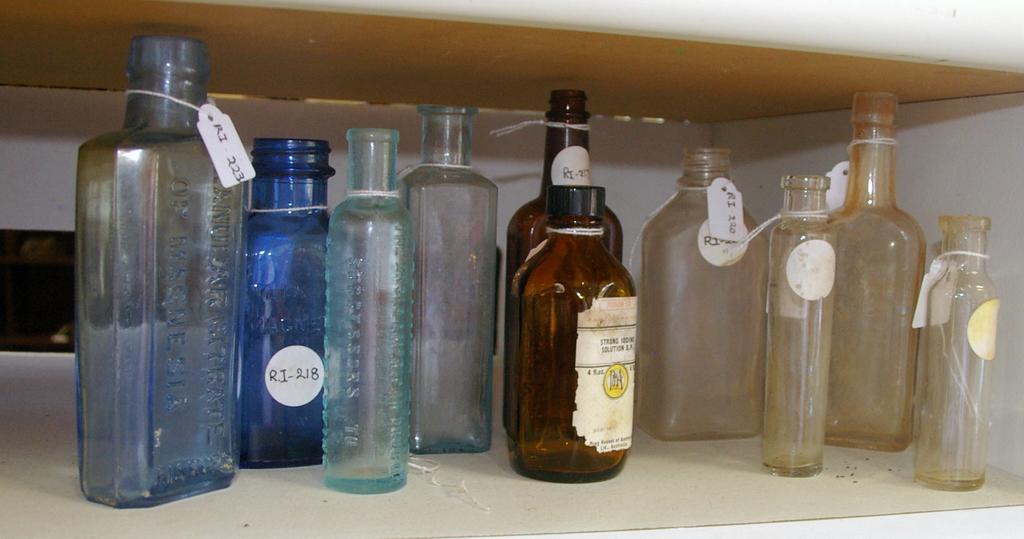The blue bottle is labeled as what?
Give a very brief answer. Ri 218. Do the labels start with ri?
Make the answer very short. Yes. 